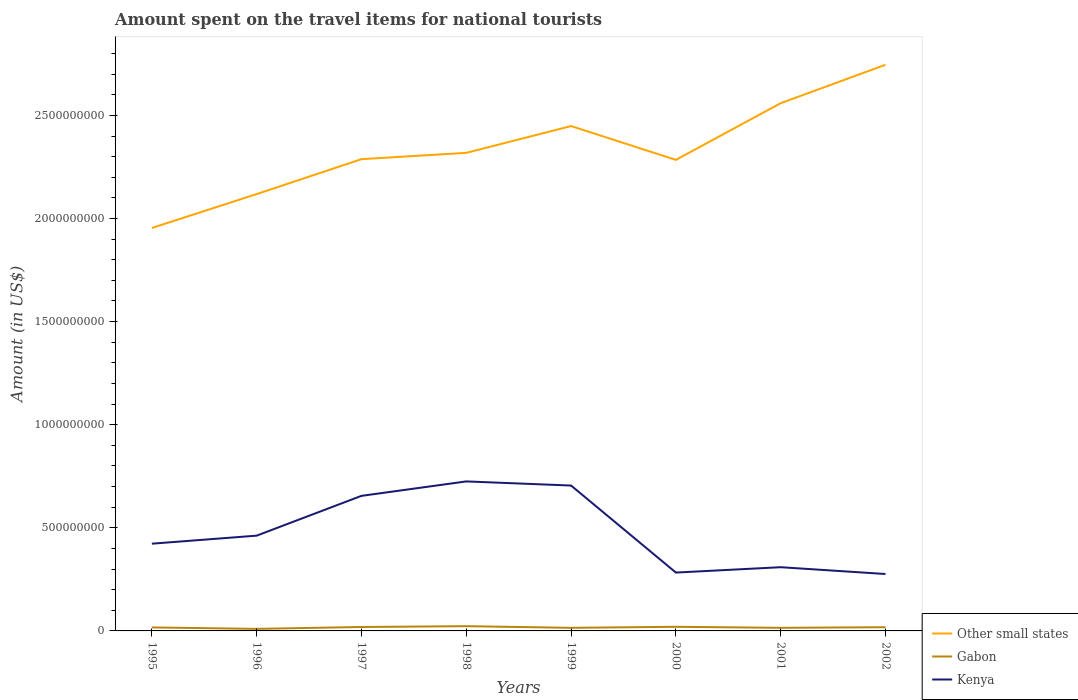How many different coloured lines are there?
Offer a terse response. 3. Is the number of lines equal to the number of legend labels?
Offer a very short reply. Yes. Across all years, what is the maximum amount spent on the travel items for national tourists in Other small states?
Provide a short and direct response. 1.95e+09. What is the total amount spent on the travel items for national tourists in Kenya in the graph?
Your answer should be compact. 3.30e+07. What is the difference between the highest and the second highest amount spent on the travel items for national tourists in Gabon?
Your response must be concise. 1.30e+07. What is the difference between the highest and the lowest amount spent on the travel items for national tourists in Kenya?
Make the answer very short. 3. Is the amount spent on the travel items for national tourists in Other small states strictly greater than the amount spent on the travel items for national tourists in Kenya over the years?
Ensure brevity in your answer.  No. How many years are there in the graph?
Make the answer very short. 8. How many legend labels are there?
Ensure brevity in your answer.  3. How are the legend labels stacked?
Give a very brief answer. Vertical. What is the title of the graph?
Give a very brief answer. Amount spent on the travel items for national tourists. Does "Palau" appear as one of the legend labels in the graph?
Your answer should be compact. No. What is the label or title of the X-axis?
Your answer should be very brief. Years. What is the label or title of the Y-axis?
Keep it short and to the point. Amount (in US$). What is the Amount (in US$) of Other small states in 1995?
Your answer should be compact. 1.95e+09. What is the Amount (in US$) in Gabon in 1995?
Provide a short and direct response. 1.70e+07. What is the Amount (in US$) in Kenya in 1995?
Provide a short and direct response. 4.23e+08. What is the Amount (in US$) in Other small states in 1996?
Give a very brief answer. 2.12e+09. What is the Amount (in US$) in Gabon in 1996?
Provide a short and direct response. 1.00e+07. What is the Amount (in US$) of Kenya in 1996?
Your answer should be compact. 4.62e+08. What is the Amount (in US$) of Other small states in 1997?
Provide a short and direct response. 2.29e+09. What is the Amount (in US$) in Gabon in 1997?
Your answer should be very brief. 1.90e+07. What is the Amount (in US$) in Kenya in 1997?
Ensure brevity in your answer.  6.55e+08. What is the Amount (in US$) of Other small states in 1998?
Offer a very short reply. 2.32e+09. What is the Amount (in US$) in Gabon in 1998?
Keep it short and to the point. 2.30e+07. What is the Amount (in US$) in Kenya in 1998?
Make the answer very short. 7.25e+08. What is the Amount (in US$) in Other small states in 1999?
Your answer should be compact. 2.45e+09. What is the Amount (in US$) of Gabon in 1999?
Keep it short and to the point. 1.50e+07. What is the Amount (in US$) of Kenya in 1999?
Offer a very short reply. 7.05e+08. What is the Amount (in US$) in Other small states in 2000?
Your response must be concise. 2.28e+09. What is the Amount (in US$) in Gabon in 2000?
Provide a short and direct response. 2.00e+07. What is the Amount (in US$) in Kenya in 2000?
Provide a short and direct response. 2.83e+08. What is the Amount (in US$) in Other small states in 2001?
Your answer should be very brief. 2.56e+09. What is the Amount (in US$) in Gabon in 2001?
Your answer should be very brief. 1.50e+07. What is the Amount (in US$) of Kenya in 2001?
Your response must be concise. 3.09e+08. What is the Amount (in US$) in Other small states in 2002?
Offer a very short reply. 2.75e+09. What is the Amount (in US$) in Gabon in 2002?
Your answer should be very brief. 1.80e+07. What is the Amount (in US$) in Kenya in 2002?
Offer a very short reply. 2.76e+08. Across all years, what is the maximum Amount (in US$) of Other small states?
Ensure brevity in your answer.  2.75e+09. Across all years, what is the maximum Amount (in US$) of Gabon?
Offer a very short reply. 2.30e+07. Across all years, what is the maximum Amount (in US$) of Kenya?
Your answer should be very brief. 7.25e+08. Across all years, what is the minimum Amount (in US$) in Other small states?
Your answer should be very brief. 1.95e+09. Across all years, what is the minimum Amount (in US$) in Kenya?
Give a very brief answer. 2.76e+08. What is the total Amount (in US$) of Other small states in the graph?
Make the answer very short. 1.87e+1. What is the total Amount (in US$) in Gabon in the graph?
Your response must be concise. 1.37e+08. What is the total Amount (in US$) in Kenya in the graph?
Your answer should be very brief. 3.84e+09. What is the difference between the Amount (in US$) in Other small states in 1995 and that in 1996?
Provide a succinct answer. -1.64e+08. What is the difference between the Amount (in US$) of Kenya in 1995 and that in 1996?
Provide a succinct answer. -3.90e+07. What is the difference between the Amount (in US$) of Other small states in 1995 and that in 1997?
Provide a succinct answer. -3.34e+08. What is the difference between the Amount (in US$) in Gabon in 1995 and that in 1997?
Offer a terse response. -2.00e+06. What is the difference between the Amount (in US$) in Kenya in 1995 and that in 1997?
Keep it short and to the point. -2.32e+08. What is the difference between the Amount (in US$) in Other small states in 1995 and that in 1998?
Make the answer very short. -3.64e+08. What is the difference between the Amount (in US$) in Gabon in 1995 and that in 1998?
Give a very brief answer. -6.00e+06. What is the difference between the Amount (in US$) in Kenya in 1995 and that in 1998?
Keep it short and to the point. -3.02e+08. What is the difference between the Amount (in US$) of Other small states in 1995 and that in 1999?
Offer a very short reply. -4.94e+08. What is the difference between the Amount (in US$) in Gabon in 1995 and that in 1999?
Give a very brief answer. 2.00e+06. What is the difference between the Amount (in US$) of Kenya in 1995 and that in 1999?
Offer a terse response. -2.82e+08. What is the difference between the Amount (in US$) of Other small states in 1995 and that in 2000?
Your answer should be very brief. -3.30e+08. What is the difference between the Amount (in US$) of Kenya in 1995 and that in 2000?
Provide a short and direct response. 1.40e+08. What is the difference between the Amount (in US$) of Other small states in 1995 and that in 2001?
Keep it short and to the point. -6.05e+08. What is the difference between the Amount (in US$) of Kenya in 1995 and that in 2001?
Your answer should be compact. 1.14e+08. What is the difference between the Amount (in US$) in Other small states in 1995 and that in 2002?
Provide a succinct answer. -7.91e+08. What is the difference between the Amount (in US$) of Gabon in 1995 and that in 2002?
Give a very brief answer. -1.00e+06. What is the difference between the Amount (in US$) in Kenya in 1995 and that in 2002?
Ensure brevity in your answer.  1.47e+08. What is the difference between the Amount (in US$) of Other small states in 1996 and that in 1997?
Your response must be concise. -1.69e+08. What is the difference between the Amount (in US$) in Gabon in 1996 and that in 1997?
Your response must be concise. -9.00e+06. What is the difference between the Amount (in US$) of Kenya in 1996 and that in 1997?
Keep it short and to the point. -1.93e+08. What is the difference between the Amount (in US$) of Other small states in 1996 and that in 1998?
Offer a terse response. -2.00e+08. What is the difference between the Amount (in US$) in Gabon in 1996 and that in 1998?
Offer a very short reply. -1.30e+07. What is the difference between the Amount (in US$) in Kenya in 1996 and that in 1998?
Give a very brief answer. -2.63e+08. What is the difference between the Amount (in US$) in Other small states in 1996 and that in 1999?
Ensure brevity in your answer.  -3.30e+08. What is the difference between the Amount (in US$) of Gabon in 1996 and that in 1999?
Ensure brevity in your answer.  -5.00e+06. What is the difference between the Amount (in US$) in Kenya in 1996 and that in 1999?
Make the answer very short. -2.43e+08. What is the difference between the Amount (in US$) in Other small states in 1996 and that in 2000?
Offer a terse response. -1.66e+08. What is the difference between the Amount (in US$) in Gabon in 1996 and that in 2000?
Offer a very short reply. -1.00e+07. What is the difference between the Amount (in US$) in Kenya in 1996 and that in 2000?
Offer a terse response. 1.79e+08. What is the difference between the Amount (in US$) in Other small states in 1996 and that in 2001?
Give a very brief answer. -4.41e+08. What is the difference between the Amount (in US$) of Gabon in 1996 and that in 2001?
Offer a very short reply. -5.00e+06. What is the difference between the Amount (in US$) in Kenya in 1996 and that in 2001?
Give a very brief answer. 1.53e+08. What is the difference between the Amount (in US$) in Other small states in 1996 and that in 2002?
Ensure brevity in your answer.  -6.27e+08. What is the difference between the Amount (in US$) in Gabon in 1996 and that in 2002?
Provide a short and direct response. -8.00e+06. What is the difference between the Amount (in US$) of Kenya in 1996 and that in 2002?
Make the answer very short. 1.86e+08. What is the difference between the Amount (in US$) in Other small states in 1997 and that in 1998?
Keep it short and to the point. -3.07e+07. What is the difference between the Amount (in US$) of Gabon in 1997 and that in 1998?
Offer a terse response. -4.00e+06. What is the difference between the Amount (in US$) of Kenya in 1997 and that in 1998?
Provide a succinct answer. -7.00e+07. What is the difference between the Amount (in US$) of Other small states in 1997 and that in 1999?
Your response must be concise. -1.61e+08. What is the difference between the Amount (in US$) in Gabon in 1997 and that in 1999?
Ensure brevity in your answer.  4.00e+06. What is the difference between the Amount (in US$) of Kenya in 1997 and that in 1999?
Provide a short and direct response. -5.00e+07. What is the difference between the Amount (in US$) of Other small states in 1997 and that in 2000?
Your answer should be compact. 3.42e+06. What is the difference between the Amount (in US$) of Kenya in 1997 and that in 2000?
Your answer should be very brief. 3.72e+08. What is the difference between the Amount (in US$) of Other small states in 1997 and that in 2001?
Provide a succinct answer. -2.72e+08. What is the difference between the Amount (in US$) in Kenya in 1997 and that in 2001?
Your response must be concise. 3.46e+08. What is the difference between the Amount (in US$) of Other small states in 1997 and that in 2002?
Ensure brevity in your answer.  -4.58e+08. What is the difference between the Amount (in US$) in Kenya in 1997 and that in 2002?
Your answer should be compact. 3.79e+08. What is the difference between the Amount (in US$) of Other small states in 1998 and that in 1999?
Offer a very short reply. -1.30e+08. What is the difference between the Amount (in US$) in Other small states in 1998 and that in 2000?
Make the answer very short. 3.41e+07. What is the difference between the Amount (in US$) of Kenya in 1998 and that in 2000?
Offer a very short reply. 4.42e+08. What is the difference between the Amount (in US$) of Other small states in 1998 and that in 2001?
Offer a terse response. -2.41e+08. What is the difference between the Amount (in US$) of Kenya in 1998 and that in 2001?
Offer a terse response. 4.16e+08. What is the difference between the Amount (in US$) in Other small states in 1998 and that in 2002?
Give a very brief answer. -4.27e+08. What is the difference between the Amount (in US$) in Gabon in 1998 and that in 2002?
Your response must be concise. 5.00e+06. What is the difference between the Amount (in US$) of Kenya in 1998 and that in 2002?
Your answer should be very brief. 4.49e+08. What is the difference between the Amount (in US$) of Other small states in 1999 and that in 2000?
Provide a succinct answer. 1.64e+08. What is the difference between the Amount (in US$) of Gabon in 1999 and that in 2000?
Offer a very short reply. -5.00e+06. What is the difference between the Amount (in US$) in Kenya in 1999 and that in 2000?
Provide a short and direct response. 4.22e+08. What is the difference between the Amount (in US$) in Other small states in 1999 and that in 2001?
Give a very brief answer. -1.11e+08. What is the difference between the Amount (in US$) of Gabon in 1999 and that in 2001?
Offer a very short reply. 0. What is the difference between the Amount (in US$) in Kenya in 1999 and that in 2001?
Offer a very short reply. 3.96e+08. What is the difference between the Amount (in US$) of Other small states in 1999 and that in 2002?
Offer a very short reply. -2.97e+08. What is the difference between the Amount (in US$) in Kenya in 1999 and that in 2002?
Provide a succinct answer. 4.29e+08. What is the difference between the Amount (in US$) in Other small states in 2000 and that in 2001?
Your answer should be very brief. -2.75e+08. What is the difference between the Amount (in US$) in Gabon in 2000 and that in 2001?
Your answer should be compact. 5.00e+06. What is the difference between the Amount (in US$) of Kenya in 2000 and that in 2001?
Keep it short and to the point. -2.60e+07. What is the difference between the Amount (in US$) in Other small states in 2000 and that in 2002?
Ensure brevity in your answer.  -4.61e+08. What is the difference between the Amount (in US$) of Other small states in 2001 and that in 2002?
Keep it short and to the point. -1.86e+08. What is the difference between the Amount (in US$) of Kenya in 2001 and that in 2002?
Your response must be concise. 3.30e+07. What is the difference between the Amount (in US$) in Other small states in 1995 and the Amount (in US$) in Gabon in 1996?
Keep it short and to the point. 1.94e+09. What is the difference between the Amount (in US$) of Other small states in 1995 and the Amount (in US$) of Kenya in 1996?
Offer a very short reply. 1.49e+09. What is the difference between the Amount (in US$) of Gabon in 1995 and the Amount (in US$) of Kenya in 1996?
Offer a very short reply. -4.45e+08. What is the difference between the Amount (in US$) of Other small states in 1995 and the Amount (in US$) of Gabon in 1997?
Keep it short and to the point. 1.93e+09. What is the difference between the Amount (in US$) of Other small states in 1995 and the Amount (in US$) of Kenya in 1997?
Your response must be concise. 1.30e+09. What is the difference between the Amount (in US$) in Gabon in 1995 and the Amount (in US$) in Kenya in 1997?
Your response must be concise. -6.38e+08. What is the difference between the Amount (in US$) in Other small states in 1995 and the Amount (in US$) in Gabon in 1998?
Offer a terse response. 1.93e+09. What is the difference between the Amount (in US$) of Other small states in 1995 and the Amount (in US$) of Kenya in 1998?
Keep it short and to the point. 1.23e+09. What is the difference between the Amount (in US$) of Gabon in 1995 and the Amount (in US$) of Kenya in 1998?
Your response must be concise. -7.08e+08. What is the difference between the Amount (in US$) in Other small states in 1995 and the Amount (in US$) in Gabon in 1999?
Offer a very short reply. 1.94e+09. What is the difference between the Amount (in US$) in Other small states in 1995 and the Amount (in US$) in Kenya in 1999?
Give a very brief answer. 1.25e+09. What is the difference between the Amount (in US$) in Gabon in 1995 and the Amount (in US$) in Kenya in 1999?
Your answer should be compact. -6.88e+08. What is the difference between the Amount (in US$) in Other small states in 1995 and the Amount (in US$) in Gabon in 2000?
Offer a very short reply. 1.93e+09. What is the difference between the Amount (in US$) in Other small states in 1995 and the Amount (in US$) in Kenya in 2000?
Give a very brief answer. 1.67e+09. What is the difference between the Amount (in US$) of Gabon in 1995 and the Amount (in US$) of Kenya in 2000?
Ensure brevity in your answer.  -2.66e+08. What is the difference between the Amount (in US$) in Other small states in 1995 and the Amount (in US$) in Gabon in 2001?
Provide a short and direct response. 1.94e+09. What is the difference between the Amount (in US$) of Other small states in 1995 and the Amount (in US$) of Kenya in 2001?
Make the answer very short. 1.64e+09. What is the difference between the Amount (in US$) of Gabon in 1995 and the Amount (in US$) of Kenya in 2001?
Provide a short and direct response. -2.92e+08. What is the difference between the Amount (in US$) in Other small states in 1995 and the Amount (in US$) in Gabon in 2002?
Provide a succinct answer. 1.94e+09. What is the difference between the Amount (in US$) in Other small states in 1995 and the Amount (in US$) in Kenya in 2002?
Keep it short and to the point. 1.68e+09. What is the difference between the Amount (in US$) of Gabon in 1995 and the Amount (in US$) of Kenya in 2002?
Your answer should be very brief. -2.59e+08. What is the difference between the Amount (in US$) of Other small states in 1996 and the Amount (in US$) of Gabon in 1997?
Ensure brevity in your answer.  2.10e+09. What is the difference between the Amount (in US$) of Other small states in 1996 and the Amount (in US$) of Kenya in 1997?
Make the answer very short. 1.46e+09. What is the difference between the Amount (in US$) of Gabon in 1996 and the Amount (in US$) of Kenya in 1997?
Ensure brevity in your answer.  -6.45e+08. What is the difference between the Amount (in US$) of Other small states in 1996 and the Amount (in US$) of Gabon in 1998?
Your answer should be compact. 2.10e+09. What is the difference between the Amount (in US$) of Other small states in 1996 and the Amount (in US$) of Kenya in 1998?
Ensure brevity in your answer.  1.39e+09. What is the difference between the Amount (in US$) in Gabon in 1996 and the Amount (in US$) in Kenya in 1998?
Your answer should be compact. -7.15e+08. What is the difference between the Amount (in US$) of Other small states in 1996 and the Amount (in US$) of Gabon in 1999?
Make the answer very short. 2.10e+09. What is the difference between the Amount (in US$) in Other small states in 1996 and the Amount (in US$) in Kenya in 1999?
Keep it short and to the point. 1.41e+09. What is the difference between the Amount (in US$) of Gabon in 1996 and the Amount (in US$) of Kenya in 1999?
Your response must be concise. -6.95e+08. What is the difference between the Amount (in US$) in Other small states in 1996 and the Amount (in US$) in Gabon in 2000?
Offer a very short reply. 2.10e+09. What is the difference between the Amount (in US$) in Other small states in 1996 and the Amount (in US$) in Kenya in 2000?
Your answer should be very brief. 1.84e+09. What is the difference between the Amount (in US$) of Gabon in 1996 and the Amount (in US$) of Kenya in 2000?
Your response must be concise. -2.73e+08. What is the difference between the Amount (in US$) in Other small states in 1996 and the Amount (in US$) in Gabon in 2001?
Provide a short and direct response. 2.10e+09. What is the difference between the Amount (in US$) in Other small states in 1996 and the Amount (in US$) in Kenya in 2001?
Offer a terse response. 1.81e+09. What is the difference between the Amount (in US$) in Gabon in 1996 and the Amount (in US$) in Kenya in 2001?
Your answer should be very brief. -2.99e+08. What is the difference between the Amount (in US$) in Other small states in 1996 and the Amount (in US$) in Gabon in 2002?
Provide a succinct answer. 2.10e+09. What is the difference between the Amount (in US$) in Other small states in 1996 and the Amount (in US$) in Kenya in 2002?
Give a very brief answer. 1.84e+09. What is the difference between the Amount (in US$) of Gabon in 1996 and the Amount (in US$) of Kenya in 2002?
Your response must be concise. -2.66e+08. What is the difference between the Amount (in US$) in Other small states in 1997 and the Amount (in US$) in Gabon in 1998?
Your answer should be compact. 2.26e+09. What is the difference between the Amount (in US$) of Other small states in 1997 and the Amount (in US$) of Kenya in 1998?
Keep it short and to the point. 1.56e+09. What is the difference between the Amount (in US$) in Gabon in 1997 and the Amount (in US$) in Kenya in 1998?
Your response must be concise. -7.06e+08. What is the difference between the Amount (in US$) of Other small states in 1997 and the Amount (in US$) of Gabon in 1999?
Provide a short and direct response. 2.27e+09. What is the difference between the Amount (in US$) of Other small states in 1997 and the Amount (in US$) of Kenya in 1999?
Provide a short and direct response. 1.58e+09. What is the difference between the Amount (in US$) of Gabon in 1997 and the Amount (in US$) of Kenya in 1999?
Make the answer very short. -6.86e+08. What is the difference between the Amount (in US$) of Other small states in 1997 and the Amount (in US$) of Gabon in 2000?
Offer a very short reply. 2.27e+09. What is the difference between the Amount (in US$) in Other small states in 1997 and the Amount (in US$) in Kenya in 2000?
Provide a succinct answer. 2.00e+09. What is the difference between the Amount (in US$) in Gabon in 1997 and the Amount (in US$) in Kenya in 2000?
Ensure brevity in your answer.  -2.64e+08. What is the difference between the Amount (in US$) of Other small states in 1997 and the Amount (in US$) of Gabon in 2001?
Keep it short and to the point. 2.27e+09. What is the difference between the Amount (in US$) of Other small states in 1997 and the Amount (in US$) of Kenya in 2001?
Offer a very short reply. 1.98e+09. What is the difference between the Amount (in US$) of Gabon in 1997 and the Amount (in US$) of Kenya in 2001?
Give a very brief answer. -2.90e+08. What is the difference between the Amount (in US$) of Other small states in 1997 and the Amount (in US$) of Gabon in 2002?
Offer a terse response. 2.27e+09. What is the difference between the Amount (in US$) of Other small states in 1997 and the Amount (in US$) of Kenya in 2002?
Your answer should be very brief. 2.01e+09. What is the difference between the Amount (in US$) in Gabon in 1997 and the Amount (in US$) in Kenya in 2002?
Ensure brevity in your answer.  -2.57e+08. What is the difference between the Amount (in US$) in Other small states in 1998 and the Amount (in US$) in Gabon in 1999?
Make the answer very short. 2.30e+09. What is the difference between the Amount (in US$) of Other small states in 1998 and the Amount (in US$) of Kenya in 1999?
Provide a succinct answer. 1.61e+09. What is the difference between the Amount (in US$) of Gabon in 1998 and the Amount (in US$) of Kenya in 1999?
Offer a very short reply. -6.82e+08. What is the difference between the Amount (in US$) of Other small states in 1998 and the Amount (in US$) of Gabon in 2000?
Provide a short and direct response. 2.30e+09. What is the difference between the Amount (in US$) of Other small states in 1998 and the Amount (in US$) of Kenya in 2000?
Offer a terse response. 2.04e+09. What is the difference between the Amount (in US$) of Gabon in 1998 and the Amount (in US$) of Kenya in 2000?
Offer a very short reply. -2.60e+08. What is the difference between the Amount (in US$) in Other small states in 1998 and the Amount (in US$) in Gabon in 2001?
Offer a terse response. 2.30e+09. What is the difference between the Amount (in US$) in Other small states in 1998 and the Amount (in US$) in Kenya in 2001?
Give a very brief answer. 2.01e+09. What is the difference between the Amount (in US$) of Gabon in 1998 and the Amount (in US$) of Kenya in 2001?
Provide a short and direct response. -2.86e+08. What is the difference between the Amount (in US$) in Other small states in 1998 and the Amount (in US$) in Gabon in 2002?
Your answer should be very brief. 2.30e+09. What is the difference between the Amount (in US$) in Other small states in 1998 and the Amount (in US$) in Kenya in 2002?
Your answer should be very brief. 2.04e+09. What is the difference between the Amount (in US$) of Gabon in 1998 and the Amount (in US$) of Kenya in 2002?
Your response must be concise. -2.53e+08. What is the difference between the Amount (in US$) of Other small states in 1999 and the Amount (in US$) of Gabon in 2000?
Keep it short and to the point. 2.43e+09. What is the difference between the Amount (in US$) of Other small states in 1999 and the Amount (in US$) of Kenya in 2000?
Your answer should be compact. 2.17e+09. What is the difference between the Amount (in US$) in Gabon in 1999 and the Amount (in US$) in Kenya in 2000?
Ensure brevity in your answer.  -2.68e+08. What is the difference between the Amount (in US$) in Other small states in 1999 and the Amount (in US$) in Gabon in 2001?
Offer a very short reply. 2.43e+09. What is the difference between the Amount (in US$) in Other small states in 1999 and the Amount (in US$) in Kenya in 2001?
Your answer should be very brief. 2.14e+09. What is the difference between the Amount (in US$) in Gabon in 1999 and the Amount (in US$) in Kenya in 2001?
Make the answer very short. -2.94e+08. What is the difference between the Amount (in US$) in Other small states in 1999 and the Amount (in US$) in Gabon in 2002?
Give a very brief answer. 2.43e+09. What is the difference between the Amount (in US$) of Other small states in 1999 and the Amount (in US$) of Kenya in 2002?
Ensure brevity in your answer.  2.17e+09. What is the difference between the Amount (in US$) in Gabon in 1999 and the Amount (in US$) in Kenya in 2002?
Provide a short and direct response. -2.61e+08. What is the difference between the Amount (in US$) of Other small states in 2000 and the Amount (in US$) of Gabon in 2001?
Your response must be concise. 2.27e+09. What is the difference between the Amount (in US$) in Other small states in 2000 and the Amount (in US$) in Kenya in 2001?
Offer a terse response. 1.98e+09. What is the difference between the Amount (in US$) in Gabon in 2000 and the Amount (in US$) in Kenya in 2001?
Offer a terse response. -2.89e+08. What is the difference between the Amount (in US$) in Other small states in 2000 and the Amount (in US$) in Gabon in 2002?
Your answer should be compact. 2.27e+09. What is the difference between the Amount (in US$) in Other small states in 2000 and the Amount (in US$) in Kenya in 2002?
Your response must be concise. 2.01e+09. What is the difference between the Amount (in US$) of Gabon in 2000 and the Amount (in US$) of Kenya in 2002?
Your answer should be compact. -2.56e+08. What is the difference between the Amount (in US$) of Other small states in 2001 and the Amount (in US$) of Gabon in 2002?
Your answer should be compact. 2.54e+09. What is the difference between the Amount (in US$) of Other small states in 2001 and the Amount (in US$) of Kenya in 2002?
Give a very brief answer. 2.28e+09. What is the difference between the Amount (in US$) of Gabon in 2001 and the Amount (in US$) of Kenya in 2002?
Your response must be concise. -2.61e+08. What is the average Amount (in US$) of Other small states per year?
Your response must be concise. 2.34e+09. What is the average Amount (in US$) of Gabon per year?
Provide a short and direct response. 1.71e+07. What is the average Amount (in US$) in Kenya per year?
Offer a terse response. 4.80e+08. In the year 1995, what is the difference between the Amount (in US$) of Other small states and Amount (in US$) of Gabon?
Your response must be concise. 1.94e+09. In the year 1995, what is the difference between the Amount (in US$) in Other small states and Amount (in US$) in Kenya?
Keep it short and to the point. 1.53e+09. In the year 1995, what is the difference between the Amount (in US$) of Gabon and Amount (in US$) of Kenya?
Give a very brief answer. -4.06e+08. In the year 1996, what is the difference between the Amount (in US$) of Other small states and Amount (in US$) of Gabon?
Your answer should be compact. 2.11e+09. In the year 1996, what is the difference between the Amount (in US$) in Other small states and Amount (in US$) in Kenya?
Provide a succinct answer. 1.66e+09. In the year 1996, what is the difference between the Amount (in US$) of Gabon and Amount (in US$) of Kenya?
Offer a very short reply. -4.52e+08. In the year 1997, what is the difference between the Amount (in US$) in Other small states and Amount (in US$) in Gabon?
Make the answer very short. 2.27e+09. In the year 1997, what is the difference between the Amount (in US$) in Other small states and Amount (in US$) in Kenya?
Make the answer very short. 1.63e+09. In the year 1997, what is the difference between the Amount (in US$) in Gabon and Amount (in US$) in Kenya?
Offer a terse response. -6.36e+08. In the year 1998, what is the difference between the Amount (in US$) of Other small states and Amount (in US$) of Gabon?
Give a very brief answer. 2.30e+09. In the year 1998, what is the difference between the Amount (in US$) of Other small states and Amount (in US$) of Kenya?
Your answer should be compact. 1.59e+09. In the year 1998, what is the difference between the Amount (in US$) of Gabon and Amount (in US$) of Kenya?
Keep it short and to the point. -7.02e+08. In the year 1999, what is the difference between the Amount (in US$) in Other small states and Amount (in US$) in Gabon?
Keep it short and to the point. 2.43e+09. In the year 1999, what is the difference between the Amount (in US$) of Other small states and Amount (in US$) of Kenya?
Offer a very short reply. 1.74e+09. In the year 1999, what is the difference between the Amount (in US$) of Gabon and Amount (in US$) of Kenya?
Provide a short and direct response. -6.90e+08. In the year 2000, what is the difference between the Amount (in US$) in Other small states and Amount (in US$) in Gabon?
Offer a very short reply. 2.26e+09. In the year 2000, what is the difference between the Amount (in US$) of Other small states and Amount (in US$) of Kenya?
Your response must be concise. 2.00e+09. In the year 2000, what is the difference between the Amount (in US$) in Gabon and Amount (in US$) in Kenya?
Your answer should be very brief. -2.63e+08. In the year 2001, what is the difference between the Amount (in US$) of Other small states and Amount (in US$) of Gabon?
Give a very brief answer. 2.54e+09. In the year 2001, what is the difference between the Amount (in US$) in Other small states and Amount (in US$) in Kenya?
Your answer should be very brief. 2.25e+09. In the year 2001, what is the difference between the Amount (in US$) in Gabon and Amount (in US$) in Kenya?
Give a very brief answer. -2.94e+08. In the year 2002, what is the difference between the Amount (in US$) of Other small states and Amount (in US$) of Gabon?
Offer a terse response. 2.73e+09. In the year 2002, what is the difference between the Amount (in US$) of Other small states and Amount (in US$) of Kenya?
Your answer should be very brief. 2.47e+09. In the year 2002, what is the difference between the Amount (in US$) of Gabon and Amount (in US$) of Kenya?
Offer a very short reply. -2.58e+08. What is the ratio of the Amount (in US$) of Other small states in 1995 to that in 1996?
Your response must be concise. 0.92. What is the ratio of the Amount (in US$) of Kenya in 1995 to that in 1996?
Make the answer very short. 0.92. What is the ratio of the Amount (in US$) in Other small states in 1995 to that in 1997?
Give a very brief answer. 0.85. What is the ratio of the Amount (in US$) in Gabon in 1995 to that in 1997?
Provide a succinct answer. 0.89. What is the ratio of the Amount (in US$) of Kenya in 1995 to that in 1997?
Provide a short and direct response. 0.65. What is the ratio of the Amount (in US$) in Other small states in 1995 to that in 1998?
Your answer should be compact. 0.84. What is the ratio of the Amount (in US$) in Gabon in 1995 to that in 1998?
Give a very brief answer. 0.74. What is the ratio of the Amount (in US$) of Kenya in 1995 to that in 1998?
Make the answer very short. 0.58. What is the ratio of the Amount (in US$) in Other small states in 1995 to that in 1999?
Your answer should be very brief. 0.8. What is the ratio of the Amount (in US$) in Gabon in 1995 to that in 1999?
Your answer should be very brief. 1.13. What is the ratio of the Amount (in US$) of Other small states in 1995 to that in 2000?
Your answer should be very brief. 0.86. What is the ratio of the Amount (in US$) in Kenya in 1995 to that in 2000?
Your answer should be compact. 1.49. What is the ratio of the Amount (in US$) in Other small states in 1995 to that in 2001?
Provide a succinct answer. 0.76. What is the ratio of the Amount (in US$) of Gabon in 1995 to that in 2001?
Ensure brevity in your answer.  1.13. What is the ratio of the Amount (in US$) of Kenya in 1995 to that in 2001?
Offer a very short reply. 1.37. What is the ratio of the Amount (in US$) in Other small states in 1995 to that in 2002?
Your response must be concise. 0.71. What is the ratio of the Amount (in US$) in Gabon in 1995 to that in 2002?
Keep it short and to the point. 0.94. What is the ratio of the Amount (in US$) of Kenya in 1995 to that in 2002?
Provide a succinct answer. 1.53. What is the ratio of the Amount (in US$) in Other small states in 1996 to that in 1997?
Provide a short and direct response. 0.93. What is the ratio of the Amount (in US$) in Gabon in 1996 to that in 1997?
Provide a short and direct response. 0.53. What is the ratio of the Amount (in US$) of Kenya in 1996 to that in 1997?
Provide a succinct answer. 0.71. What is the ratio of the Amount (in US$) in Other small states in 1996 to that in 1998?
Keep it short and to the point. 0.91. What is the ratio of the Amount (in US$) in Gabon in 1996 to that in 1998?
Your answer should be compact. 0.43. What is the ratio of the Amount (in US$) in Kenya in 1996 to that in 1998?
Provide a short and direct response. 0.64. What is the ratio of the Amount (in US$) of Other small states in 1996 to that in 1999?
Your response must be concise. 0.87. What is the ratio of the Amount (in US$) of Kenya in 1996 to that in 1999?
Provide a succinct answer. 0.66. What is the ratio of the Amount (in US$) in Other small states in 1996 to that in 2000?
Offer a terse response. 0.93. What is the ratio of the Amount (in US$) in Gabon in 1996 to that in 2000?
Offer a terse response. 0.5. What is the ratio of the Amount (in US$) of Kenya in 1996 to that in 2000?
Your answer should be compact. 1.63. What is the ratio of the Amount (in US$) in Other small states in 1996 to that in 2001?
Your response must be concise. 0.83. What is the ratio of the Amount (in US$) of Gabon in 1996 to that in 2001?
Your answer should be very brief. 0.67. What is the ratio of the Amount (in US$) of Kenya in 1996 to that in 2001?
Offer a terse response. 1.5. What is the ratio of the Amount (in US$) of Other small states in 1996 to that in 2002?
Your answer should be compact. 0.77. What is the ratio of the Amount (in US$) of Gabon in 1996 to that in 2002?
Provide a succinct answer. 0.56. What is the ratio of the Amount (in US$) in Kenya in 1996 to that in 2002?
Your response must be concise. 1.67. What is the ratio of the Amount (in US$) in Other small states in 1997 to that in 1998?
Your answer should be very brief. 0.99. What is the ratio of the Amount (in US$) in Gabon in 1997 to that in 1998?
Give a very brief answer. 0.83. What is the ratio of the Amount (in US$) of Kenya in 1997 to that in 1998?
Provide a succinct answer. 0.9. What is the ratio of the Amount (in US$) of Other small states in 1997 to that in 1999?
Make the answer very short. 0.93. What is the ratio of the Amount (in US$) in Gabon in 1997 to that in 1999?
Provide a succinct answer. 1.27. What is the ratio of the Amount (in US$) in Kenya in 1997 to that in 1999?
Ensure brevity in your answer.  0.93. What is the ratio of the Amount (in US$) in Gabon in 1997 to that in 2000?
Ensure brevity in your answer.  0.95. What is the ratio of the Amount (in US$) in Kenya in 1997 to that in 2000?
Offer a terse response. 2.31. What is the ratio of the Amount (in US$) in Other small states in 1997 to that in 2001?
Your answer should be compact. 0.89. What is the ratio of the Amount (in US$) of Gabon in 1997 to that in 2001?
Offer a terse response. 1.27. What is the ratio of the Amount (in US$) of Kenya in 1997 to that in 2001?
Give a very brief answer. 2.12. What is the ratio of the Amount (in US$) in Gabon in 1997 to that in 2002?
Provide a short and direct response. 1.06. What is the ratio of the Amount (in US$) of Kenya in 1997 to that in 2002?
Your answer should be compact. 2.37. What is the ratio of the Amount (in US$) of Other small states in 1998 to that in 1999?
Provide a short and direct response. 0.95. What is the ratio of the Amount (in US$) of Gabon in 1998 to that in 1999?
Offer a terse response. 1.53. What is the ratio of the Amount (in US$) in Kenya in 1998 to that in 1999?
Your response must be concise. 1.03. What is the ratio of the Amount (in US$) of Other small states in 1998 to that in 2000?
Provide a succinct answer. 1.01. What is the ratio of the Amount (in US$) of Gabon in 1998 to that in 2000?
Make the answer very short. 1.15. What is the ratio of the Amount (in US$) in Kenya in 1998 to that in 2000?
Make the answer very short. 2.56. What is the ratio of the Amount (in US$) in Other small states in 1998 to that in 2001?
Offer a very short reply. 0.91. What is the ratio of the Amount (in US$) of Gabon in 1998 to that in 2001?
Ensure brevity in your answer.  1.53. What is the ratio of the Amount (in US$) of Kenya in 1998 to that in 2001?
Offer a terse response. 2.35. What is the ratio of the Amount (in US$) of Other small states in 1998 to that in 2002?
Offer a very short reply. 0.84. What is the ratio of the Amount (in US$) of Gabon in 1998 to that in 2002?
Ensure brevity in your answer.  1.28. What is the ratio of the Amount (in US$) of Kenya in 1998 to that in 2002?
Offer a terse response. 2.63. What is the ratio of the Amount (in US$) in Other small states in 1999 to that in 2000?
Your answer should be compact. 1.07. What is the ratio of the Amount (in US$) of Gabon in 1999 to that in 2000?
Ensure brevity in your answer.  0.75. What is the ratio of the Amount (in US$) in Kenya in 1999 to that in 2000?
Provide a short and direct response. 2.49. What is the ratio of the Amount (in US$) in Other small states in 1999 to that in 2001?
Ensure brevity in your answer.  0.96. What is the ratio of the Amount (in US$) of Gabon in 1999 to that in 2001?
Your response must be concise. 1. What is the ratio of the Amount (in US$) of Kenya in 1999 to that in 2001?
Your answer should be very brief. 2.28. What is the ratio of the Amount (in US$) in Other small states in 1999 to that in 2002?
Offer a terse response. 0.89. What is the ratio of the Amount (in US$) of Kenya in 1999 to that in 2002?
Your response must be concise. 2.55. What is the ratio of the Amount (in US$) of Other small states in 2000 to that in 2001?
Make the answer very short. 0.89. What is the ratio of the Amount (in US$) of Kenya in 2000 to that in 2001?
Ensure brevity in your answer.  0.92. What is the ratio of the Amount (in US$) of Other small states in 2000 to that in 2002?
Your answer should be compact. 0.83. What is the ratio of the Amount (in US$) of Kenya in 2000 to that in 2002?
Provide a succinct answer. 1.03. What is the ratio of the Amount (in US$) of Other small states in 2001 to that in 2002?
Your answer should be compact. 0.93. What is the ratio of the Amount (in US$) in Gabon in 2001 to that in 2002?
Your answer should be compact. 0.83. What is the ratio of the Amount (in US$) of Kenya in 2001 to that in 2002?
Provide a succinct answer. 1.12. What is the difference between the highest and the second highest Amount (in US$) in Other small states?
Make the answer very short. 1.86e+08. What is the difference between the highest and the second highest Amount (in US$) in Gabon?
Give a very brief answer. 3.00e+06. What is the difference between the highest and the lowest Amount (in US$) in Other small states?
Keep it short and to the point. 7.91e+08. What is the difference between the highest and the lowest Amount (in US$) of Gabon?
Give a very brief answer. 1.30e+07. What is the difference between the highest and the lowest Amount (in US$) in Kenya?
Provide a short and direct response. 4.49e+08. 